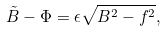<formula> <loc_0><loc_0><loc_500><loc_500>\tilde { B } - \Phi = \epsilon \sqrt { B ^ { 2 } - f ^ { 2 } } ,</formula> 